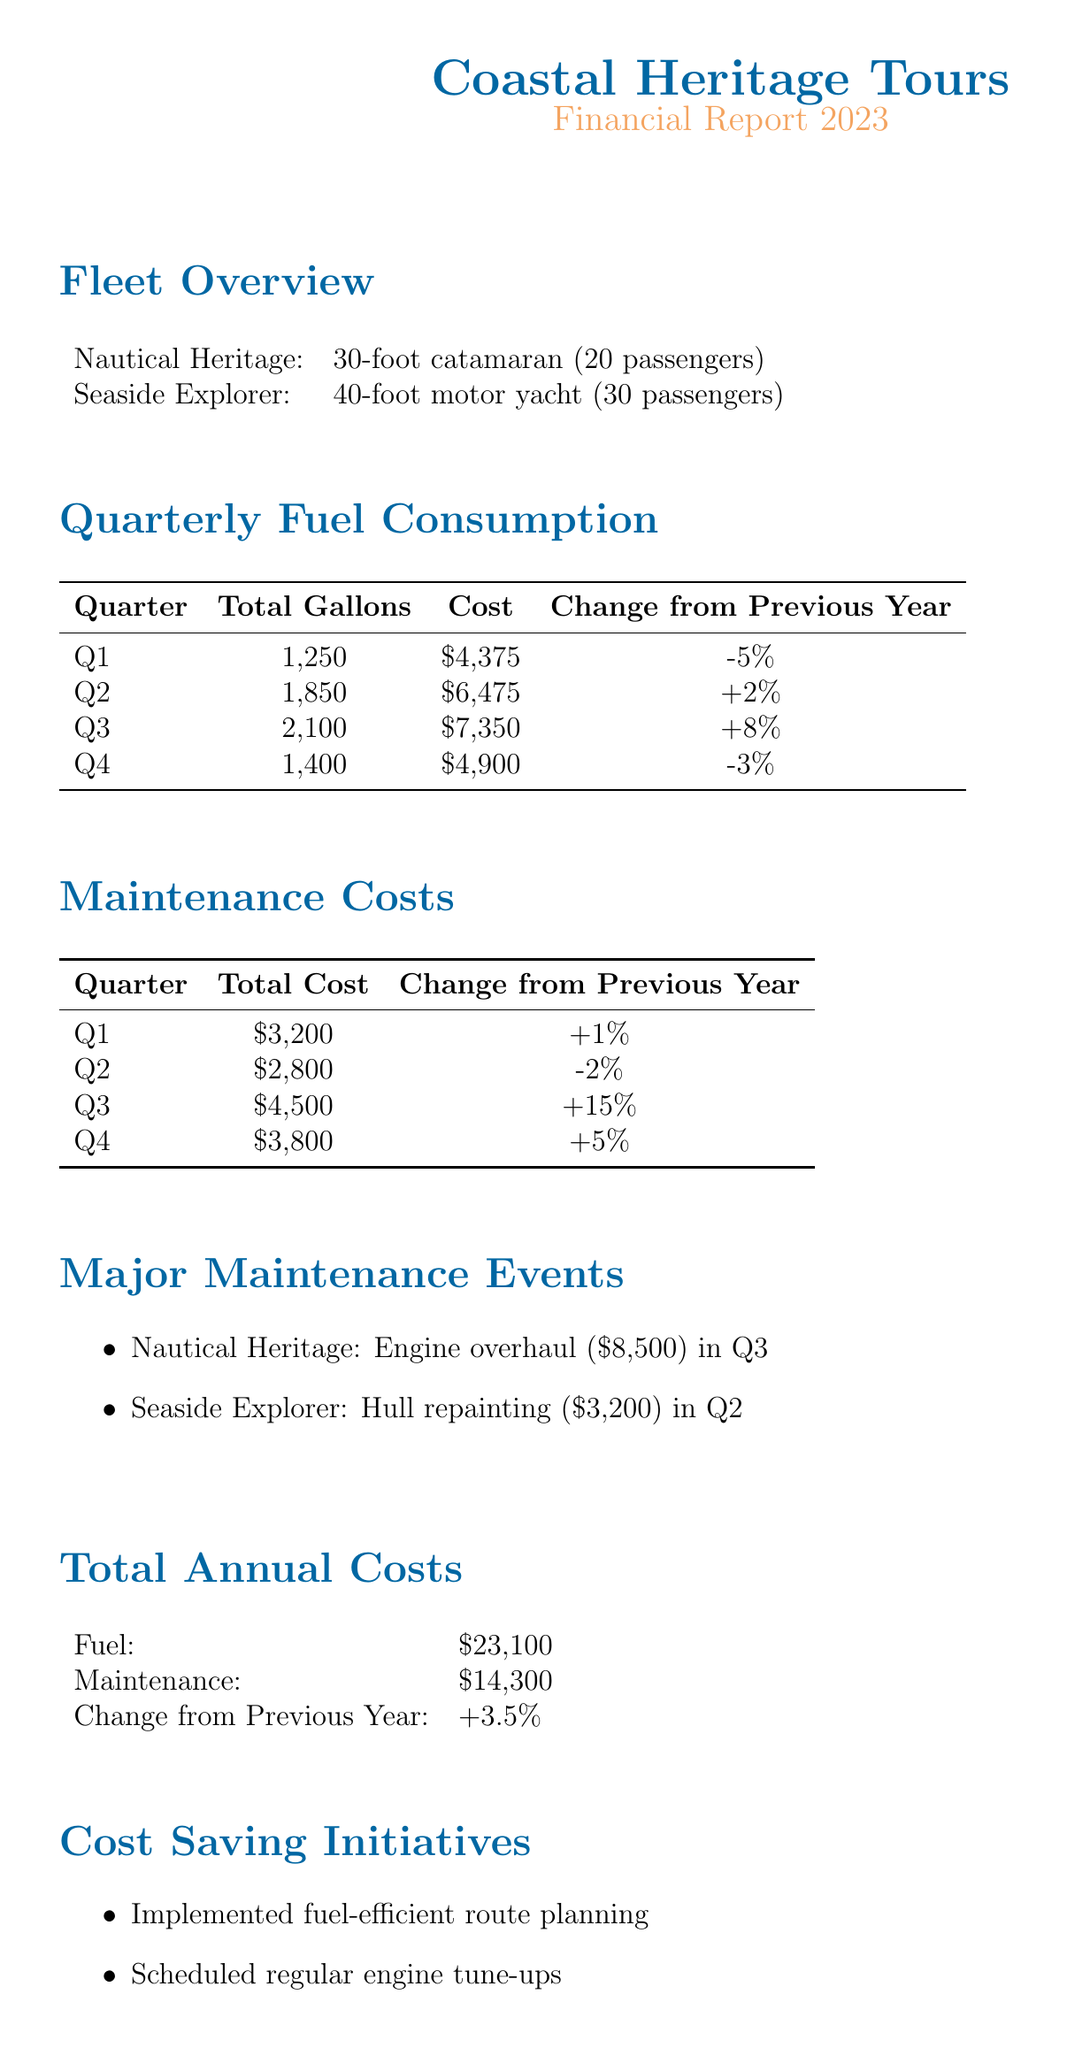What is the total fuel consumption in Q2? The total fuel consumption in Q2 is stated as 1850 gallons in the document.
Answer: 1850 gallons What was the maintenance cost in Q3? According to the document, the maintenance cost in Q3 is $4,500.
Answer: $4,500 What is the change in total fuel costs from Q1 to Q2? The document shows that the change in total fuel costs from Q1 to Q2 is +2%.
Answer: +2% What major maintenance event occurred in Q2? The document lists hull repainting for the Seaside Explorer as a major maintenance event in Q2.
Answer: Hull repainting What is the total annual maintenance cost? The total annual maintenance cost for 2023 is specified as $14,300 in the document.
Answer: $14,300 How much did the engine overhaul cost? The cost of the engine overhaul for Nautical Heritage is stated as $8,500.
Answer: $8,500 What initiative was implemented to save costs? The document mentions implementing fuel-efficient route planning as one of the cost-saving initiatives.
Answer: Fuel-efficient route planning What was the change in total annual costs compared to the previous year? The change in total annual costs from the previous year is +3.5%, as per the document.
Answer: +3.5% What type of boat is the Nautical Heritage? The document specifies that the Nautical Heritage is a 30-foot catamaran.
Answer: 30-foot catamaran 